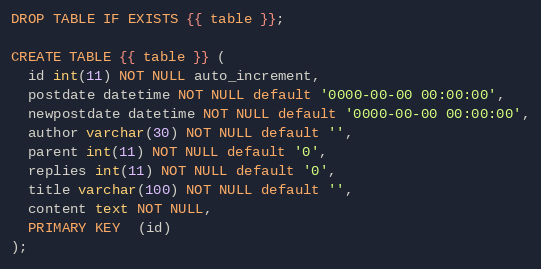<code> <loc_0><loc_0><loc_500><loc_500><_SQL_>DROP TABLE IF EXISTS {{ table }};

CREATE TABLE {{ table }} (
  id int(11) NOT NULL auto_increment,
  postdate datetime NOT NULL default '0000-00-00 00:00:00',
  newpostdate datetime NOT NULL default '0000-00-00 00:00:00',
  author varchar(30) NOT NULL default '',
  parent int(11) NOT NULL default '0',
  replies int(11) NOT NULL default '0',
  title varchar(100) NOT NULL default '',
  content text NOT NULL,
  PRIMARY KEY  (id)
);</code> 